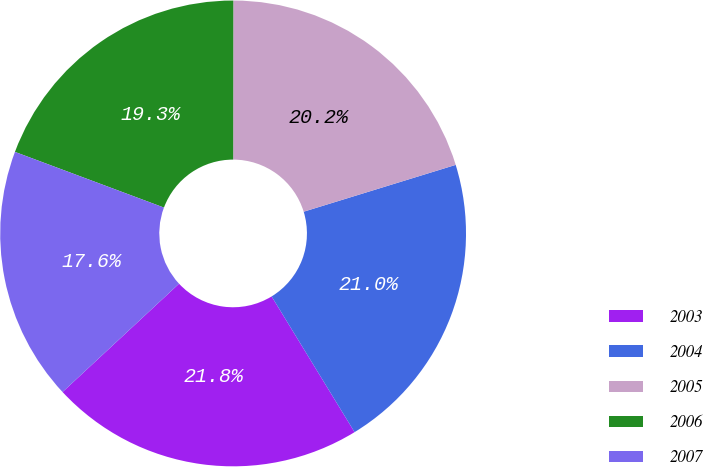<chart> <loc_0><loc_0><loc_500><loc_500><pie_chart><fcel>2003<fcel>2004<fcel>2005<fcel>2006<fcel>2007<nl><fcel>21.81%<fcel>21.02%<fcel>20.23%<fcel>19.32%<fcel>17.61%<nl></chart> 